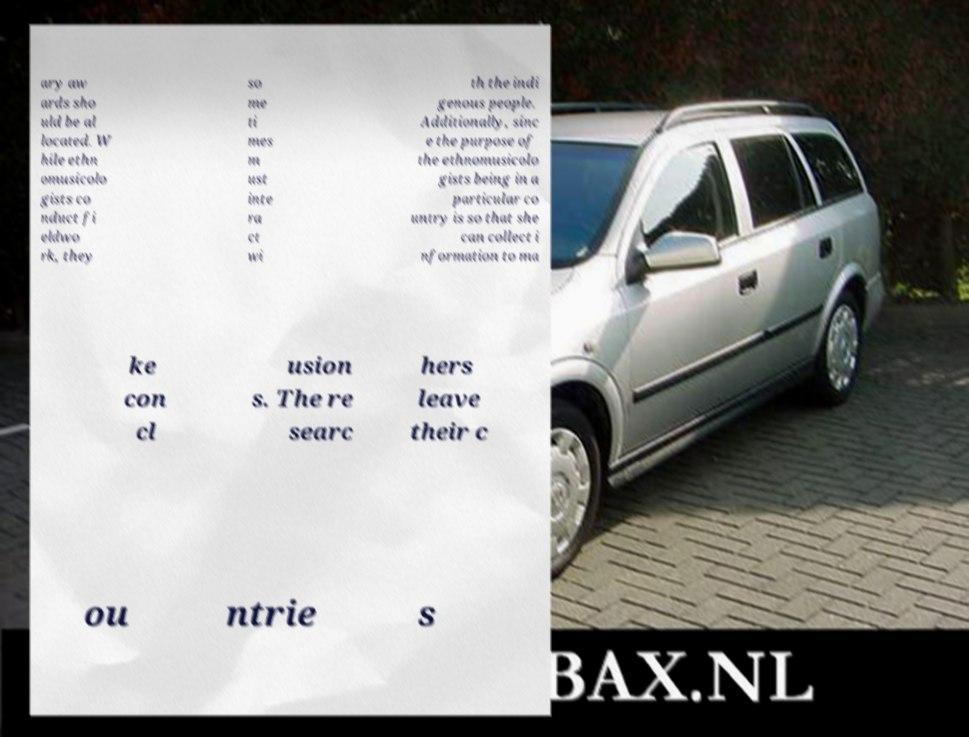For documentation purposes, I need the text within this image transcribed. Could you provide that? ary aw ards sho uld be al located. W hile ethn omusicolo gists co nduct fi eldwo rk, they so me ti mes m ust inte ra ct wi th the indi genous people. Additionally, sinc e the purpose of the ethnomusicolo gists being in a particular co untry is so that she can collect i nformation to ma ke con cl usion s. The re searc hers leave their c ou ntrie s 